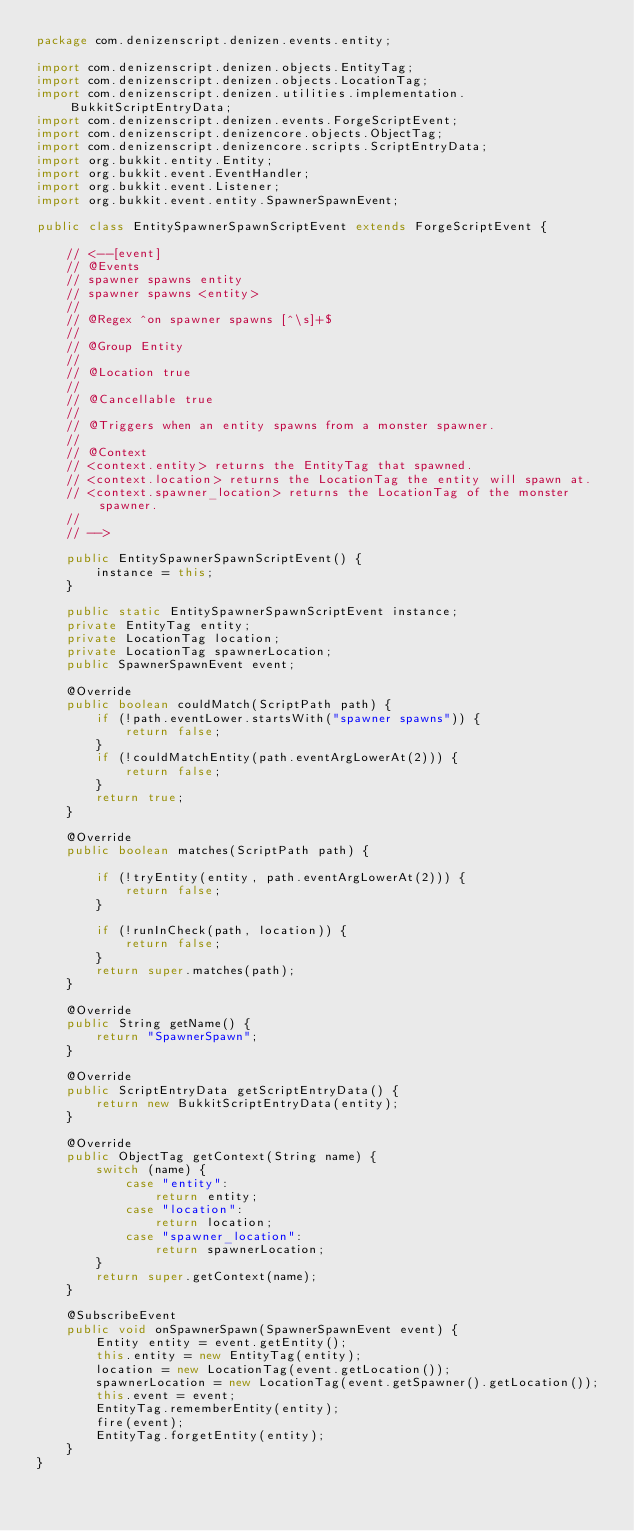Convert code to text. <code><loc_0><loc_0><loc_500><loc_500><_Java_>package com.denizenscript.denizen.events.entity;

import com.denizenscript.denizen.objects.EntityTag;
import com.denizenscript.denizen.objects.LocationTag;
import com.denizenscript.denizen.utilities.implementation.BukkitScriptEntryData;
import com.denizenscript.denizen.events.ForgeScriptEvent;
import com.denizenscript.denizencore.objects.ObjectTag;
import com.denizenscript.denizencore.scripts.ScriptEntryData;
import org.bukkit.entity.Entity;
import org.bukkit.event.EventHandler;
import org.bukkit.event.Listener;
import org.bukkit.event.entity.SpawnerSpawnEvent;

public class EntitySpawnerSpawnScriptEvent extends ForgeScriptEvent {

    // <--[event]
    // @Events
    // spawner spawns entity
    // spawner spawns <entity>
    //
    // @Regex ^on spawner spawns [^\s]+$
    //
    // @Group Entity
    //
    // @Location true
    //
    // @Cancellable true
    //
    // @Triggers when an entity spawns from a monster spawner.
    //
    // @Context
    // <context.entity> returns the EntityTag that spawned.
    // <context.location> returns the LocationTag the entity will spawn at.
    // <context.spawner_location> returns the LocationTag of the monster spawner.
    //
    // -->

    public EntitySpawnerSpawnScriptEvent() {
        instance = this;
    }

    public static EntitySpawnerSpawnScriptEvent instance;
    private EntityTag entity;
    private LocationTag location;
    private LocationTag spawnerLocation;
    public SpawnerSpawnEvent event;

    @Override
    public boolean couldMatch(ScriptPath path) {
        if (!path.eventLower.startsWith("spawner spawns")) {
            return false;
        }
        if (!couldMatchEntity(path.eventArgLowerAt(2))) {
            return false;
        }
        return true;
    }

    @Override
    public boolean matches(ScriptPath path) {

        if (!tryEntity(entity, path.eventArgLowerAt(2))) {
            return false;
        }

        if (!runInCheck(path, location)) {
            return false;
        }
        return super.matches(path);
    }

    @Override
    public String getName() {
        return "SpawnerSpawn";
    }

    @Override
    public ScriptEntryData getScriptEntryData() {
        return new BukkitScriptEntryData(entity);
    }

    @Override
    public ObjectTag getContext(String name) {
        switch (name) {
            case "entity":
                return entity;
            case "location":
                return location;
            case "spawner_location":
                return spawnerLocation;
        }
        return super.getContext(name);
    }

    @SubscribeEvent
    public void onSpawnerSpawn(SpawnerSpawnEvent event) {
        Entity entity = event.getEntity();
        this.entity = new EntityTag(entity);
        location = new LocationTag(event.getLocation());
        spawnerLocation = new LocationTag(event.getSpawner().getLocation());
        this.event = event;
        EntityTag.rememberEntity(entity);
        fire(event);
        EntityTag.forgetEntity(entity);
    }
}
</code> 